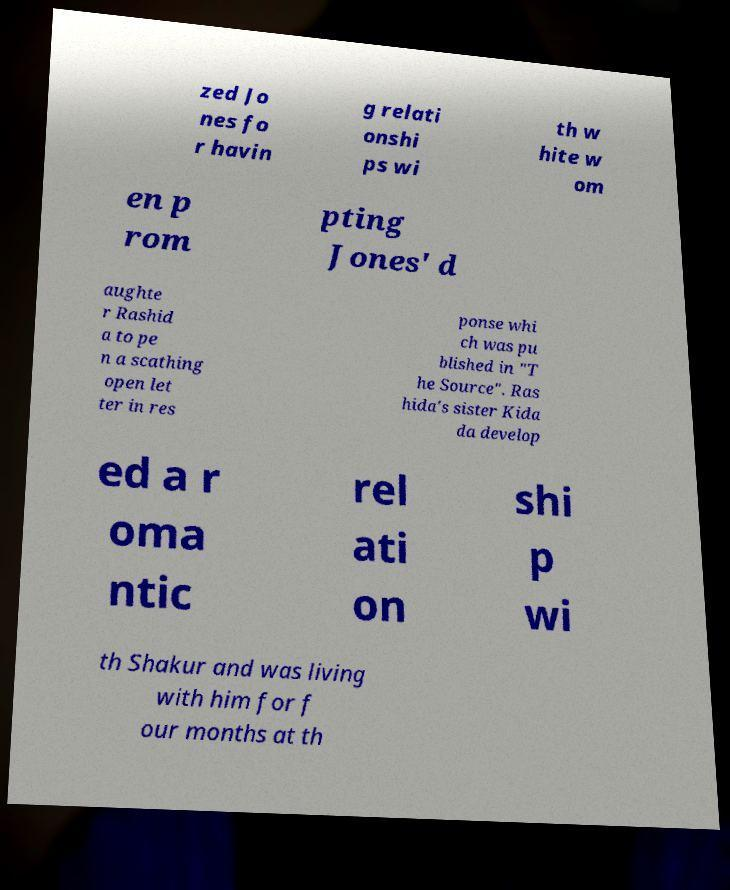What messages or text are displayed in this image? I need them in a readable, typed format. zed Jo nes fo r havin g relati onshi ps wi th w hite w om en p rom pting Jones' d aughte r Rashid a to pe n a scathing open let ter in res ponse whi ch was pu blished in "T he Source". Ras hida's sister Kida da develop ed a r oma ntic rel ati on shi p wi th Shakur and was living with him for f our months at th 